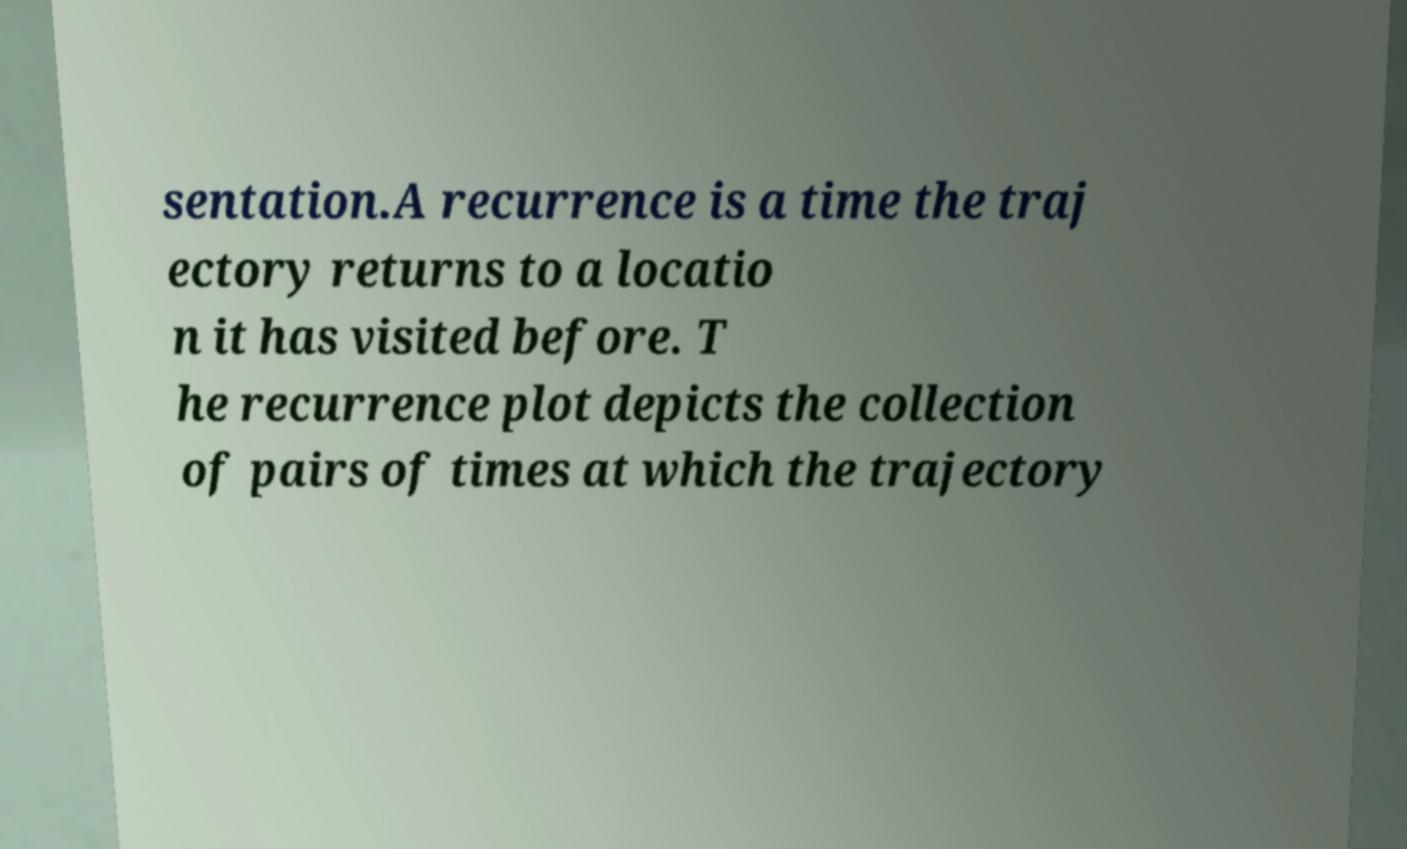Can you read and provide the text displayed in the image?This photo seems to have some interesting text. Can you extract and type it out for me? sentation.A recurrence is a time the traj ectory returns to a locatio n it has visited before. T he recurrence plot depicts the collection of pairs of times at which the trajectory 